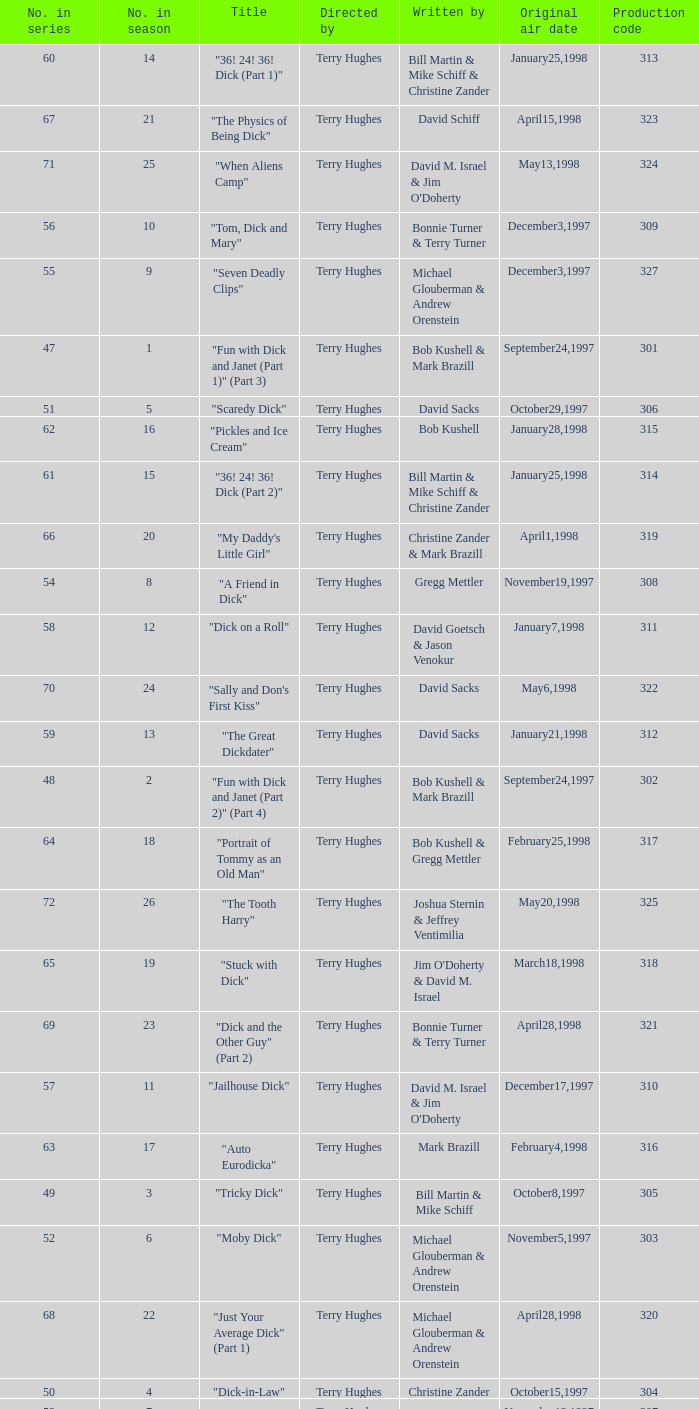What is the original air date of the episode with production code is 319? April1,1998. 